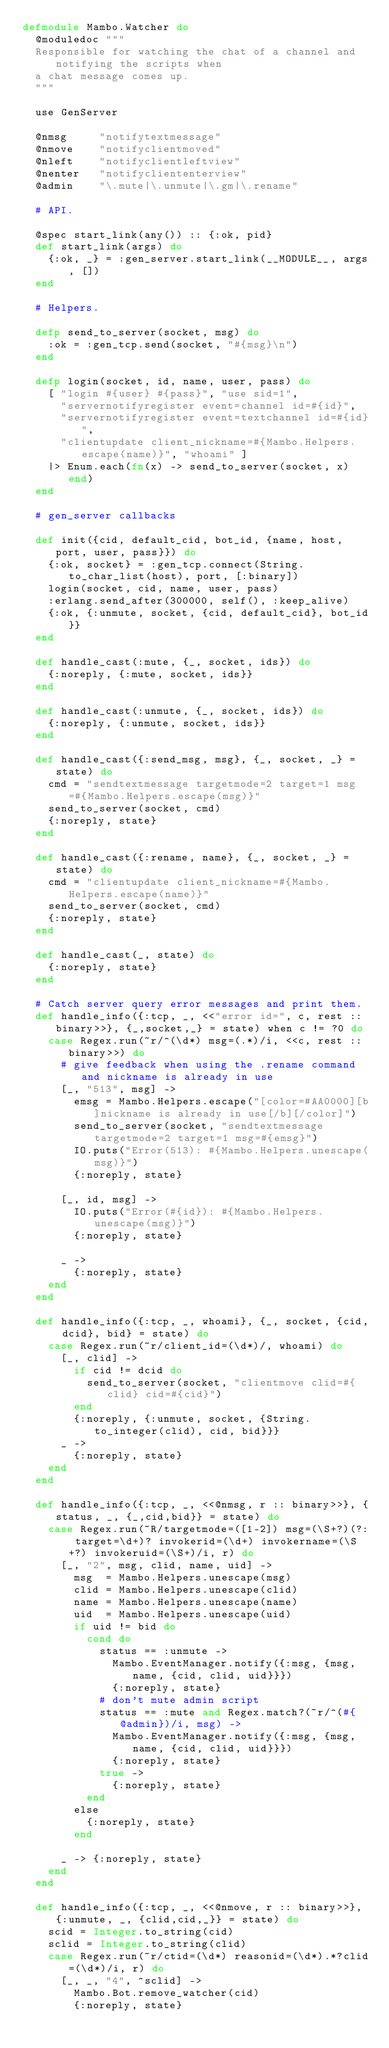Convert code to text. <code><loc_0><loc_0><loc_500><loc_500><_Elixir_>defmodule Mambo.Watcher do
  @moduledoc """
  Responsible for watching the chat of a channel and notifying the scripts when
  a chat message comes up.
  """

  use GenServer

  @nmsg     "notifytextmessage"
  @nmove    "notifyclientmoved"
  @nleft    "notifyclientleftview"
  @nenter   "notifycliententerview"
  @admin    "\.mute|\.unmute|\.gm|\.rename"

  # API.

  @spec start_link(any()) :: {:ok, pid}
  def start_link(args) do
    {:ok, _} = :gen_server.start_link(__MODULE__, args, [])
  end

  # Helpers.

  defp send_to_server(socket, msg) do
    :ok = :gen_tcp.send(socket, "#{msg}\n")
  end

  defp login(socket, id, name, user, pass) do
    [ "login #{user} #{pass}", "use sid=1",
      "servernotifyregister event=channel id=#{id}",
      "servernotifyregister event=textchannel id=#{id}",
      "clientupdate client_nickname=#{Mambo.Helpers.escape(name)}", "whoami" ]
    |> Enum.each(fn(x) -> send_to_server(socket, x) end)
  end

  # gen_server callbacks

  def init({cid, default_cid, bot_id, {name, host, port, user, pass}}) do
    {:ok, socket} = :gen_tcp.connect(String.to_char_list(host), port, [:binary])
    login(socket, cid, name, user, pass)
    :erlang.send_after(300000, self(), :keep_alive)
    {:ok, {:unmute, socket, {cid, default_cid}, bot_id}}
  end

  def handle_cast(:mute, {_, socket, ids}) do
    {:noreply, {:mute, socket, ids}}
  end

  def handle_cast(:unmute, {_, socket, ids}) do
    {:noreply, {:unmute, socket, ids}}
  end

  def handle_cast({:send_msg, msg}, {_, socket, _} = state) do
    cmd = "sendtextmessage targetmode=2 target=1 msg=#{Mambo.Helpers.escape(msg)}"
    send_to_server(socket, cmd)
    {:noreply, state}
  end

  def handle_cast({:rename, name}, {_, socket, _} = state) do
    cmd = "clientupdate client_nickname=#{Mambo.Helpers.escape(name)}"
    send_to_server(socket, cmd)
    {:noreply, state}
  end

  def handle_cast(_, state) do
    {:noreply, state}
  end

  # Catch server query error messages and print them.
  def handle_info({:tcp, _, <<"error id=", c, rest :: binary>>}, {_,socket,_} = state) when c != ?0 do
    case Regex.run(~r/^(\d*) msg=(.*)/i, <<c, rest :: binary>>) do
      # give feedback when using the .rename command and nickname is already in use
      [_, "513", msg] ->
        emsg = Mambo.Helpers.escape("[color=#AA0000][b]nickname is already in use[/b][/color]")
        send_to_server(socket, "sendtextmessage targetmode=2 target=1 msg=#{emsg}")
        IO.puts("Error(513): #{Mambo.Helpers.unescape(msg)}")
        {:noreply, state}

      [_, id, msg] ->
        IO.puts("Error(#{id}): #{Mambo.Helpers.unescape(msg)}")
        {:noreply, state}

      _ ->
        {:noreply, state}
    end
  end

  def handle_info({:tcp, _, whoami}, {_, socket, {cid, dcid}, bid} = state) do
    case Regex.run(~r/client_id=(\d*)/, whoami) do
      [_, clid] ->
        if cid != dcid do
          send_to_server(socket, "clientmove clid=#{clid} cid=#{cid}")
        end
        {:noreply, {:unmute, socket, {String.to_integer(clid), cid, bid}}}
      _ ->
        {:noreply, state}
    end
  end

  def handle_info({:tcp, _, <<@nmsg, r :: binary>>}, {status, _, {_,cid,bid}} = state) do
    case Regex.run(~R/targetmode=([1-2]) msg=(\S+?)(?: target=\d+)? invokerid=(\d+) invokername=(\S+?) invokeruid=(\S+)/i, r) do
      [_, "2", msg, clid, name, uid] ->
        msg  = Mambo.Helpers.unescape(msg)
        clid = Mambo.Helpers.unescape(clid)
        name = Mambo.Helpers.unescape(name)
        uid  = Mambo.Helpers.unescape(uid)
        if uid != bid do
          cond do
            status == :unmute ->
              Mambo.EventManager.notify({:msg, {msg, name, {cid, clid, uid}}})
              {:noreply, state}
            # don't mute admin script
            status == :mute and Regex.match?(~r/^(#{@admin})/i, msg) ->
              Mambo.EventManager.notify({:msg, {msg, name, {cid, clid, uid}}})
              {:noreply, state}
            true ->
              {:noreply, state}
          end
        else
          {:noreply, state}
        end

      _ -> {:noreply, state}
    end
  end

  def handle_info({:tcp, _, <<@nmove, r :: binary>>}, {:unmute, _, {clid,cid,_}} = state) do
    scid = Integer.to_string(cid)
    sclid = Integer.to_string(clid)
    case Regex.run(~r/ctid=(\d*) reasonid=(\d*).*?clid=(\d*)/i, r) do
      [_, _, "4", ^sclid] ->
        Mambo.Bot.remove_watcher(cid)
        {:noreply, state}
</code> 